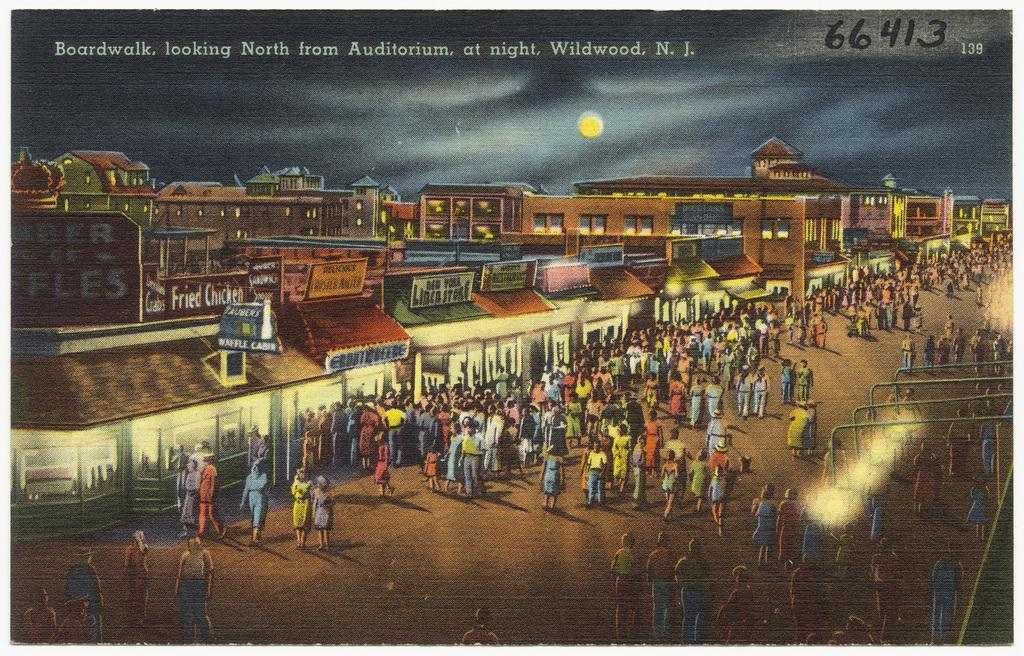What type of art is depicted in the image? The image contains art, but the specific type cannot be determined from the provided facts. Can you describe the people in the image? There are people in the image, but their appearance or actions cannot be determined from the provided facts. What kind of buildings are visible in the image? There are buildings in the image, but their architectural style or purpose cannot be determined from the provided facts. What is the purpose of the lights in the image? The purpose of the lights in the image cannot be determined from the provided facts. What do the texts in the image say? The texts in the image cannot be read or understood from the provided facts. How many tomatoes are being used in the science experiment in the image? There is no mention of tomatoes or a science experiment in the image, so this question cannot be answered. 